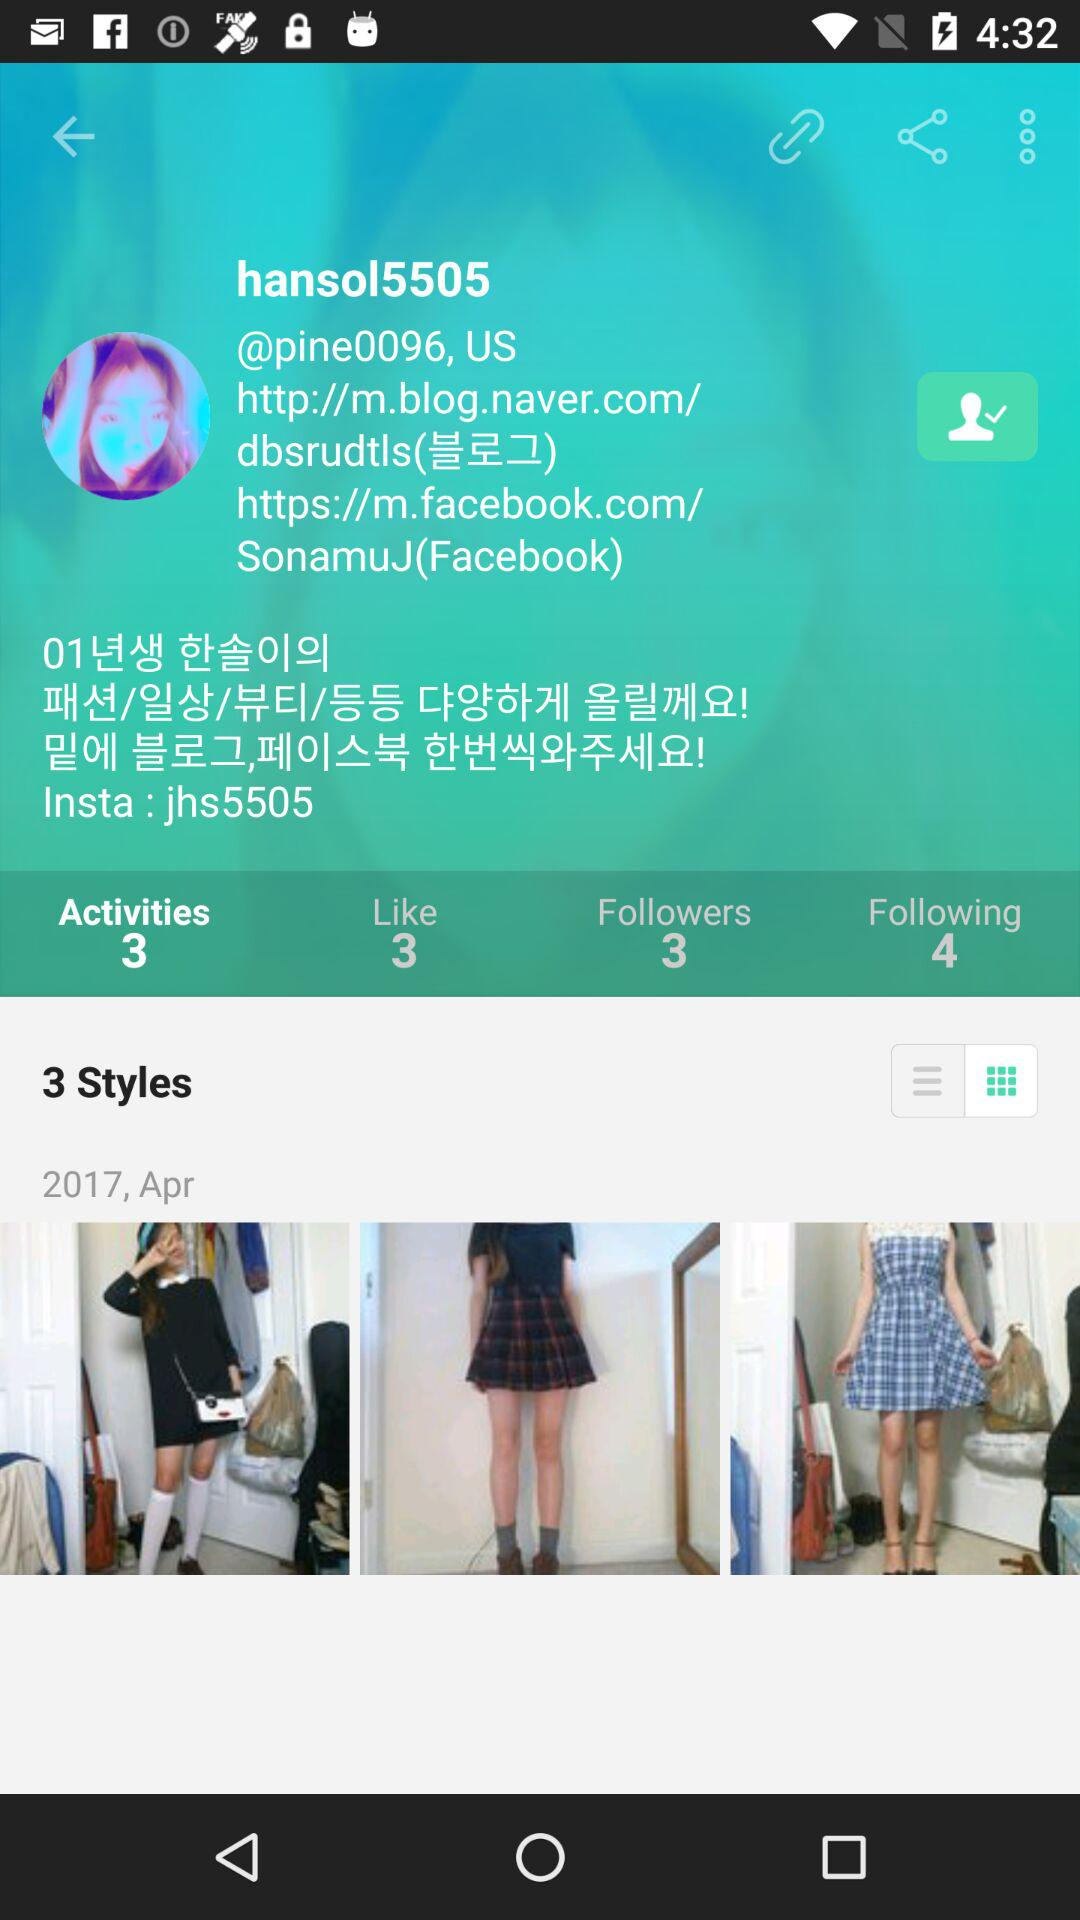What is the number of people "hansol5505" follows? "hansol5505" follows 4 people. 